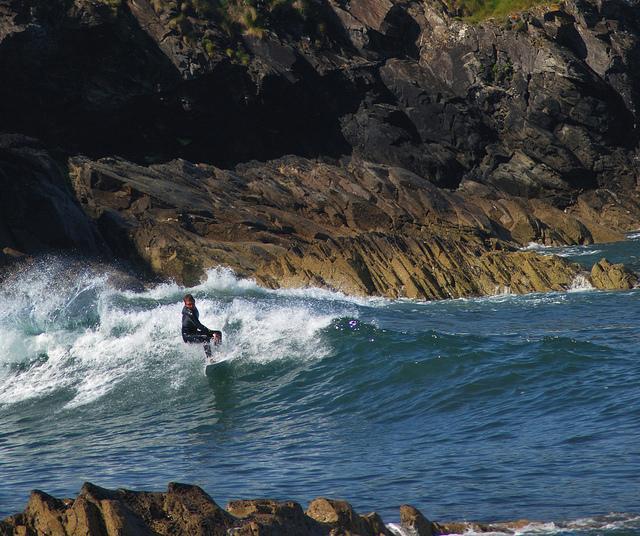How many red kites are there?
Give a very brief answer. 0. 